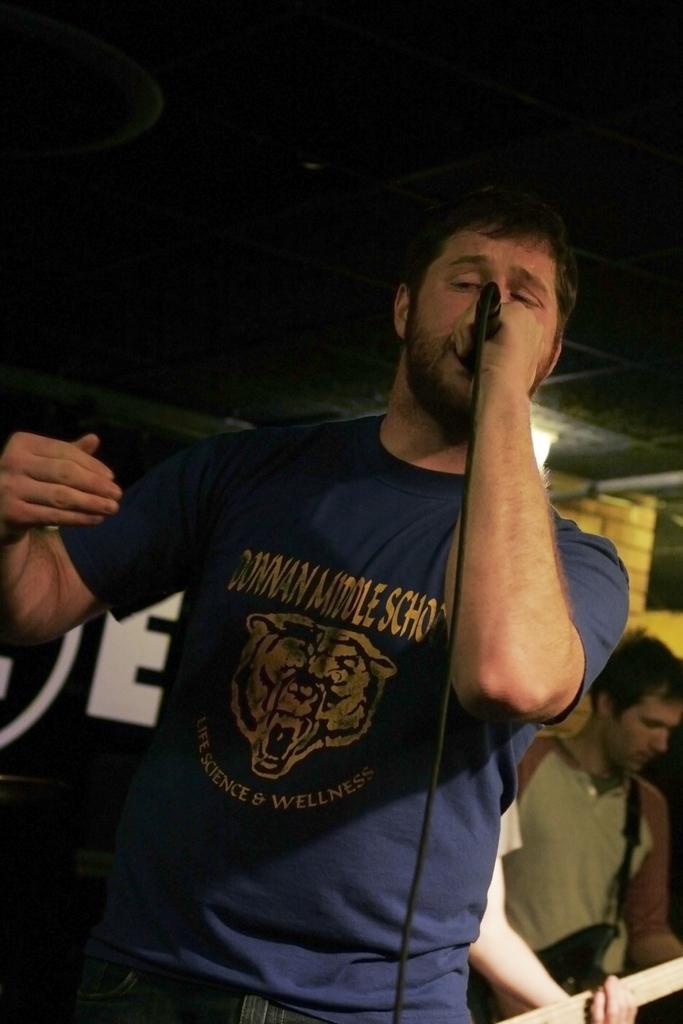How would you summarize this image in a sentence or two? In the image we can see there is a man who is holding mic in his hand and another man is standing and holding guitar in his hand. 